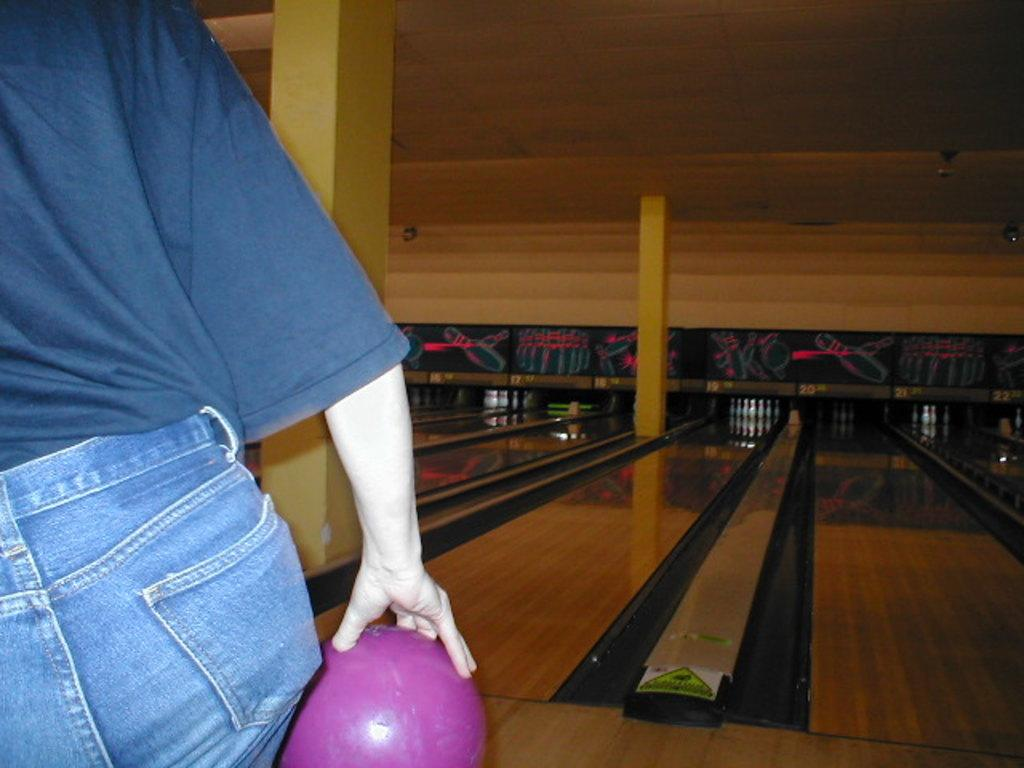Who is present in the image? There is a man in the image. Where is the man located in the image? The man is standing on the left side of the image. What is the man holding in the image? The man is holding a ball. What activity is the man engaged in? The man is playing ten pin bowling. How many ants can be seen crawling on the man's shoes in the image? There are no ants visible in the image, so it is not possible to determine how many might be crawling on the man's shoes. 